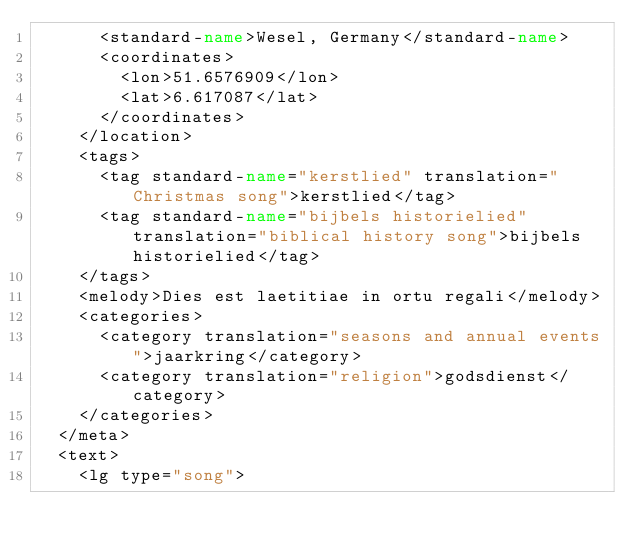Convert code to text. <code><loc_0><loc_0><loc_500><loc_500><_XML_>      <standard-name>Wesel, Germany</standard-name>
      <coordinates>
        <lon>51.6576909</lon>
        <lat>6.617087</lat>
      </coordinates>
    </location>
    <tags>
      <tag standard-name="kerstlied" translation="Christmas song">kerstlied</tag>
      <tag standard-name="bijbels historielied" translation="biblical history song">bijbels historielied</tag>
    </tags>
    <melody>Dies est laetitiae in ortu regali</melody>
    <categories>
      <category translation="seasons and annual events">jaarkring</category>
      <category translation="religion">godsdienst</category>
    </categories>
  </meta>
  <text>
    <lg type="song"></code> 